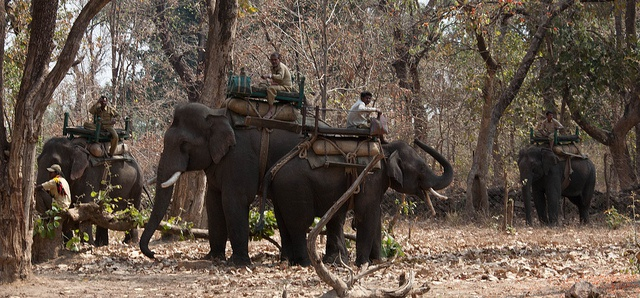Describe the objects in this image and their specific colors. I can see elephant in gray and black tones, elephant in gray, black, and maroon tones, elephant in gray and black tones, elephant in gray and black tones, and people in gray, black, and maroon tones in this image. 